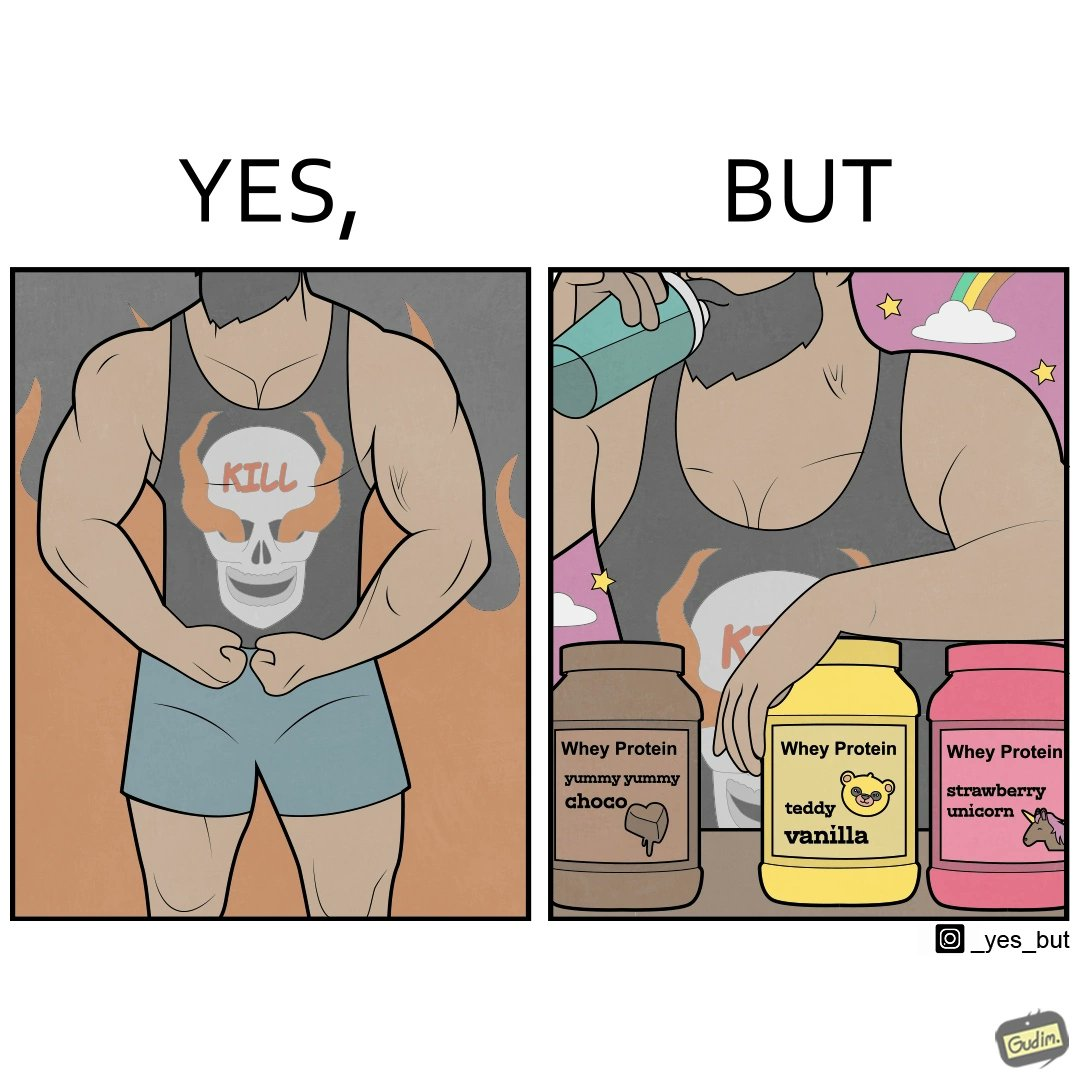What does this image depict? The image is funny because a well-built person wearing an aggressive tank-top with the word "KILL" on an image of a skull is having very childish flavours of whey protein such as teddy vanilla, yummy yummy choco, and strawberry vanilla, contrary to the person's external persona. This depicts the metaphor 'Do not judge a book by its cover'. 